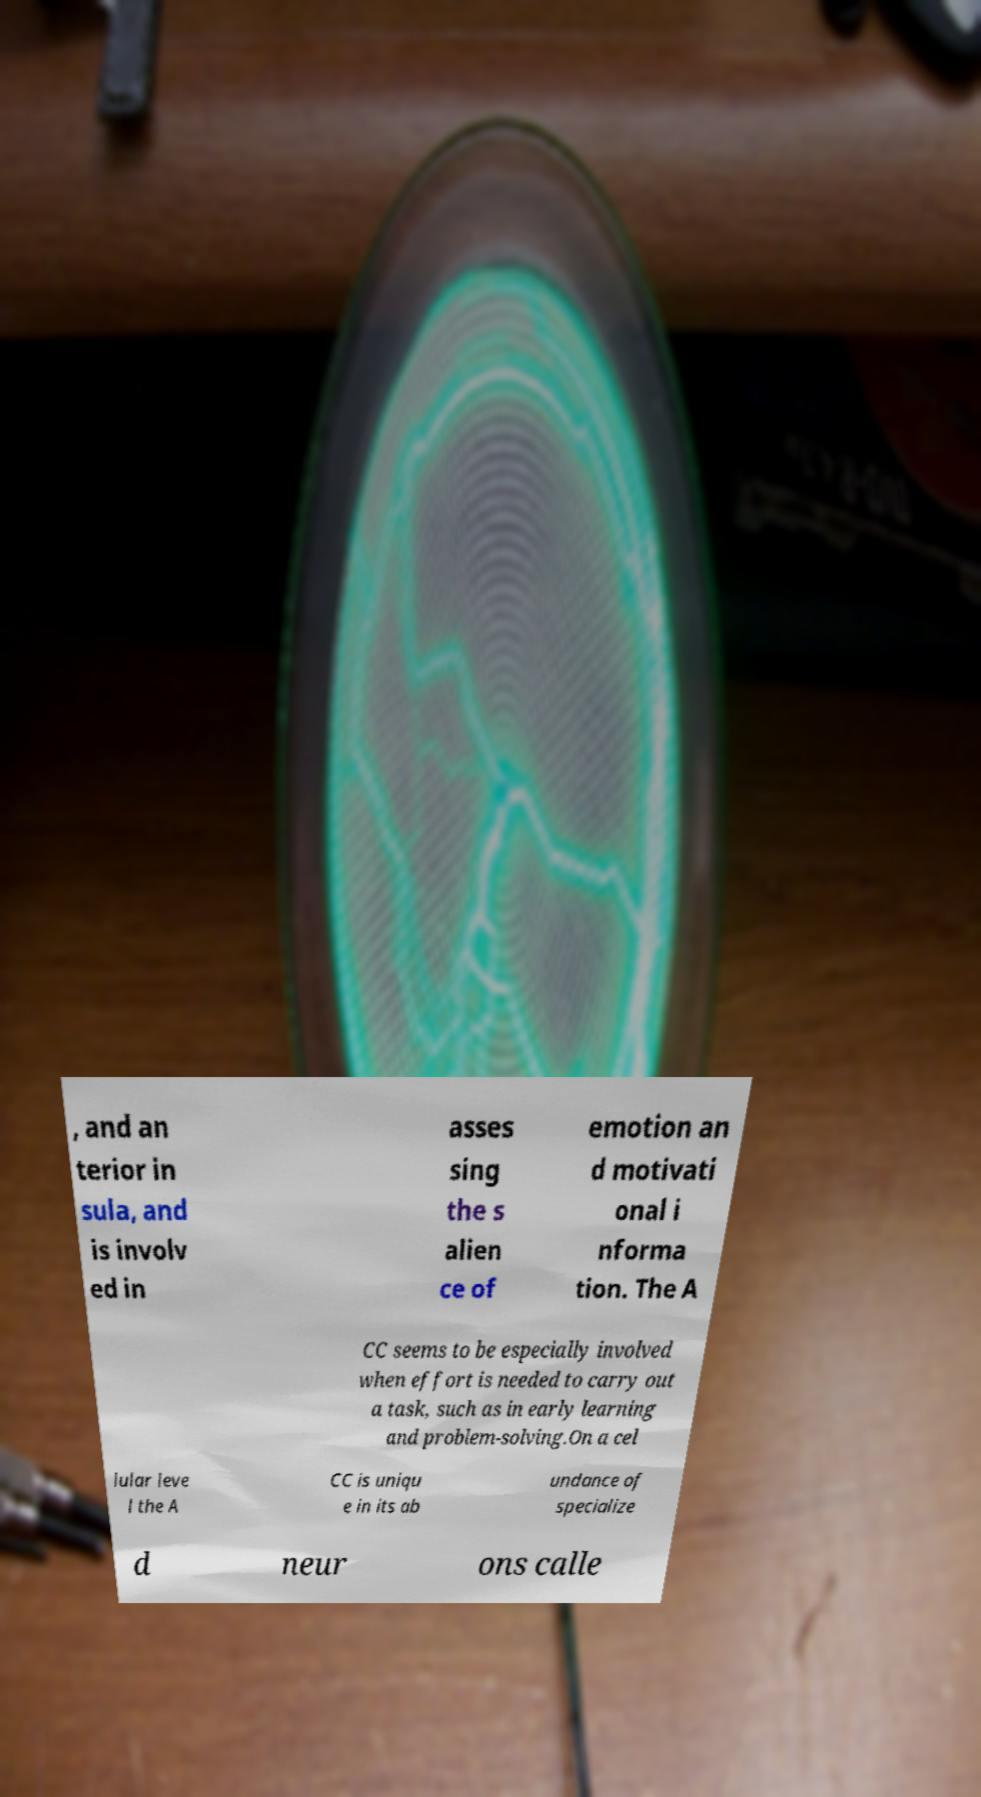Please read and relay the text visible in this image. What does it say? , and an terior in sula, and is involv ed in asses sing the s alien ce of emotion an d motivati onal i nforma tion. The A CC seems to be especially involved when effort is needed to carry out a task, such as in early learning and problem-solving.On a cel lular leve l the A CC is uniqu e in its ab undance of specialize d neur ons calle 